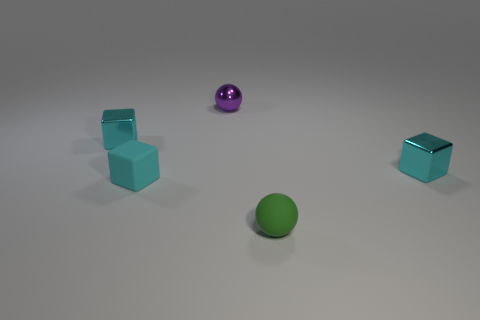How many rubber things are green things or cyan things?
Offer a very short reply. 2. Are there fewer metallic spheres in front of the tiny green rubber thing than small rubber blocks that are behind the cyan rubber object?
Your answer should be compact. No. How many things are large gray metallic spheres or blocks that are to the left of the cyan matte object?
Your response must be concise. 1. What is the material of the other green ball that is the same size as the metal ball?
Offer a very short reply. Rubber. Is the material of the small green object the same as the small purple sphere?
Ensure brevity in your answer.  No. What color is the metallic thing that is to the left of the green sphere and in front of the purple metallic thing?
Give a very brief answer. Cyan. There is a small cube that is right of the green matte ball; does it have the same color as the tiny matte block?
Ensure brevity in your answer.  Yes. The purple metal thing that is the same size as the rubber cube is what shape?
Keep it short and to the point. Sphere. How many other things are the same color as the small rubber sphere?
Provide a short and direct response. 0. What number of other objects are there of the same material as the green ball?
Provide a short and direct response. 1. 